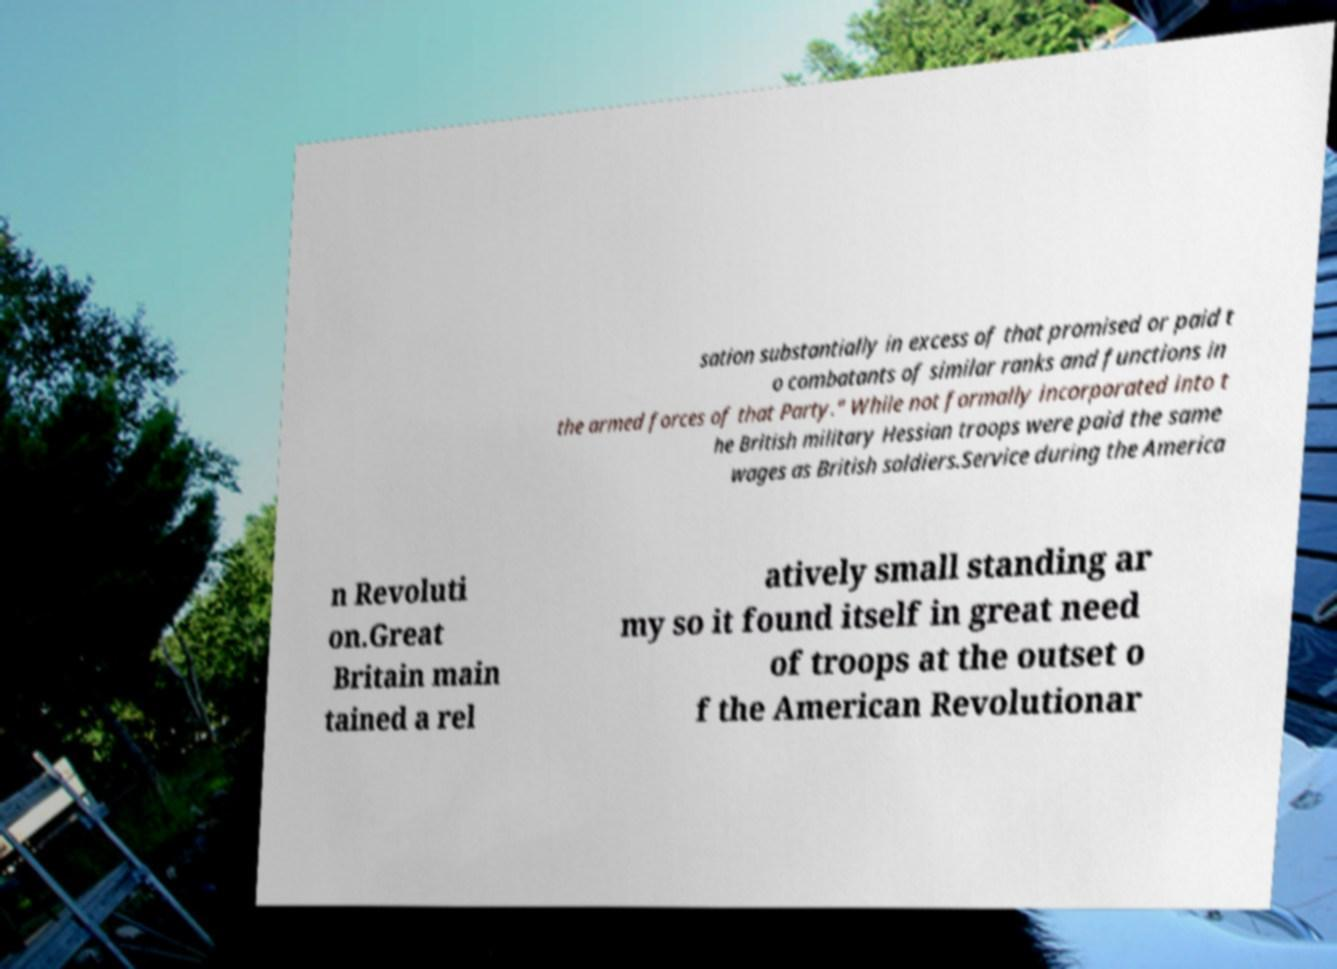Please read and relay the text visible in this image. What does it say? sation substantially in excess of that promised or paid t o combatants of similar ranks and functions in the armed forces of that Party." While not formally incorporated into t he British military Hessian troops were paid the same wages as British soldiers.Service during the America n Revoluti on.Great Britain main tained a rel atively small standing ar my so it found itself in great need of troops at the outset o f the American Revolutionar 